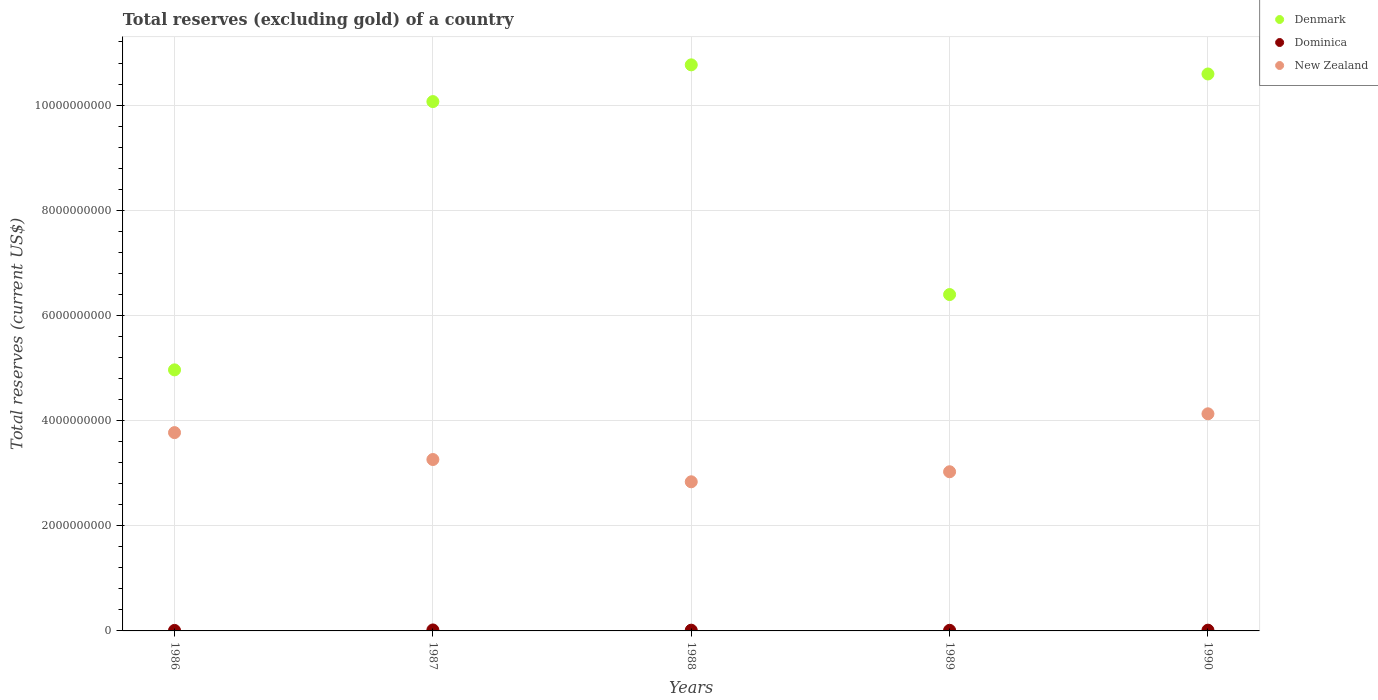What is the total reserves (excluding gold) in Denmark in 1987?
Your answer should be very brief. 1.01e+1. Across all years, what is the maximum total reserves (excluding gold) in New Zealand?
Your response must be concise. 4.13e+09. Across all years, what is the minimum total reserves (excluding gold) in New Zealand?
Keep it short and to the point. 2.84e+09. In which year was the total reserves (excluding gold) in New Zealand maximum?
Provide a succinct answer. 1990. In which year was the total reserves (excluding gold) in Denmark minimum?
Your response must be concise. 1986. What is the total total reserves (excluding gold) in Dominica in the graph?
Keep it short and to the point. 6.82e+07. What is the difference between the total reserves (excluding gold) in Dominica in 1988 and that in 1990?
Provide a succinct answer. -3.99e+05. What is the difference between the total reserves (excluding gold) in Dominica in 1989 and the total reserves (excluding gold) in Denmark in 1987?
Offer a terse response. -1.01e+1. What is the average total reserves (excluding gold) in Denmark per year?
Provide a short and direct response. 8.56e+09. In the year 1990, what is the difference between the total reserves (excluding gold) in Dominica and total reserves (excluding gold) in Denmark?
Offer a terse response. -1.06e+1. In how many years, is the total reserves (excluding gold) in Dominica greater than 4800000000 US$?
Provide a short and direct response. 0. What is the ratio of the total reserves (excluding gold) in New Zealand in 1986 to that in 1987?
Your answer should be very brief. 1.16. What is the difference between the highest and the second highest total reserves (excluding gold) in Dominica?
Give a very brief answer. 3.96e+06. What is the difference between the highest and the lowest total reserves (excluding gold) in New Zealand?
Offer a very short reply. 1.29e+09. Is the sum of the total reserves (excluding gold) in New Zealand in 1987 and 1988 greater than the maximum total reserves (excluding gold) in Denmark across all years?
Keep it short and to the point. No. Is it the case that in every year, the sum of the total reserves (excluding gold) in Dominica and total reserves (excluding gold) in Denmark  is greater than the total reserves (excluding gold) in New Zealand?
Your response must be concise. Yes. Is the total reserves (excluding gold) in New Zealand strictly less than the total reserves (excluding gold) in Denmark over the years?
Keep it short and to the point. Yes. How many dotlines are there?
Provide a succinct answer. 3. How many years are there in the graph?
Provide a succinct answer. 5. What is the difference between two consecutive major ticks on the Y-axis?
Provide a short and direct response. 2.00e+09. Does the graph contain grids?
Your response must be concise. Yes. Where does the legend appear in the graph?
Your response must be concise. Top right. How many legend labels are there?
Keep it short and to the point. 3. What is the title of the graph?
Your response must be concise. Total reserves (excluding gold) of a country. What is the label or title of the Y-axis?
Make the answer very short. Total reserves (current US$). What is the Total reserves (current US$) in Denmark in 1986?
Provide a short and direct response. 4.96e+09. What is the Total reserves (current US$) in Dominica in 1986?
Provide a short and direct response. 9.59e+06. What is the Total reserves (current US$) in New Zealand in 1986?
Provide a succinct answer. 3.77e+09. What is the Total reserves (current US$) of Denmark in 1987?
Ensure brevity in your answer.  1.01e+1. What is the Total reserves (current US$) of Dominica in 1987?
Keep it short and to the point. 1.84e+07. What is the Total reserves (current US$) of New Zealand in 1987?
Make the answer very short. 3.26e+09. What is the Total reserves (current US$) of Denmark in 1988?
Your answer should be very brief. 1.08e+1. What is the Total reserves (current US$) of Dominica in 1988?
Offer a terse response. 1.41e+07. What is the Total reserves (current US$) in New Zealand in 1988?
Your answer should be compact. 2.84e+09. What is the Total reserves (current US$) of Denmark in 1989?
Offer a terse response. 6.40e+09. What is the Total reserves (current US$) of Dominica in 1989?
Provide a succinct answer. 1.17e+07. What is the Total reserves (current US$) in New Zealand in 1989?
Your response must be concise. 3.03e+09. What is the Total reserves (current US$) of Denmark in 1990?
Make the answer very short. 1.06e+1. What is the Total reserves (current US$) of Dominica in 1990?
Provide a short and direct response. 1.45e+07. What is the Total reserves (current US$) of New Zealand in 1990?
Offer a terse response. 4.13e+09. Across all years, what is the maximum Total reserves (current US$) in Denmark?
Offer a very short reply. 1.08e+1. Across all years, what is the maximum Total reserves (current US$) of Dominica?
Ensure brevity in your answer.  1.84e+07. Across all years, what is the maximum Total reserves (current US$) of New Zealand?
Give a very brief answer. 4.13e+09. Across all years, what is the minimum Total reserves (current US$) in Denmark?
Your answer should be very brief. 4.96e+09. Across all years, what is the minimum Total reserves (current US$) of Dominica?
Provide a short and direct response. 9.59e+06. Across all years, what is the minimum Total reserves (current US$) of New Zealand?
Make the answer very short. 2.84e+09. What is the total Total reserves (current US$) in Denmark in the graph?
Provide a short and direct response. 4.28e+1. What is the total Total reserves (current US$) in Dominica in the graph?
Make the answer very short. 6.82e+07. What is the total Total reserves (current US$) in New Zealand in the graph?
Provide a succinct answer. 1.70e+1. What is the difference between the Total reserves (current US$) in Denmark in 1986 and that in 1987?
Provide a succinct answer. -5.10e+09. What is the difference between the Total reserves (current US$) in Dominica in 1986 and that in 1987?
Give a very brief answer. -8.83e+06. What is the difference between the Total reserves (current US$) in New Zealand in 1986 and that in 1987?
Offer a very short reply. 5.12e+08. What is the difference between the Total reserves (current US$) of Denmark in 1986 and that in 1988?
Provide a succinct answer. -5.80e+09. What is the difference between the Total reserves (current US$) of Dominica in 1986 and that in 1988?
Your answer should be very brief. -4.47e+06. What is the difference between the Total reserves (current US$) of New Zealand in 1986 and that in 1988?
Ensure brevity in your answer.  9.35e+08. What is the difference between the Total reserves (current US$) of Denmark in 1986 and that in 1989?
Ensure brevity in your answer.  -1.43e+09. What is the difference between the Total reserves (current US$) of Dominica in 1986 and that in 1989?
Your response must be concise. -2.09e+06. What is the difference between the Total reserves (current US$) in New Zealand in 1986 and that in 1989?
Keep it short and to the point. 7.44e+08. What is the difference between the Total reserves (current US$) of Denmark in 1986 and that in 1990?
Your response must be concise. -5.63e+09. What is the difference between the Total reserves (current US$) in Dominica in 1986 and that in 1990?
Provide a succinct answer. -4.87e+06. What is the difference between the Total reserves (current US$) in New Zealand in 1986 and that in 1990?
Make the answer very short. -3.58e+08. What is the difference between the Total reserves (current US$) in Denmark in 1987 and that in 1988?
Offer a very short reply. -6.99e+08. What is the difference between the Total reserves (current US$) of Dominica in 1987 and that in 1988?
Make the answer very short. 4.36e+06. What is the difference between the Total reserves (current US$) in New Zealand in 1987 and that in 1988?
Your response must be concise. 4.24e+08. What is the difference between the Total reserves (current US$) in Denmark in 1987 and that in 1989?
Provide a succinct answer. 3.67e+09. What is the difference between the Total reserves (current US$) of Dominica in 1987 and that in 1989?
Keep it short and to the point. 6.74e+06. What is the difference between the Total reserves (current US$) in New Zealand in 1987 and that in 1989?
Offer a very short reply. 2.33e+08. What is the difference between the Total reserves (current US$) in Denmark in 1987 and that in 1990?
Keep it short and to the point. -5.25e+08. What is the difference between the Total reserves (current US$) of Dominica in 1987 and that in 1990?
Provide a short and direct response. 3.96e+06. What is the difference between the Total reserves (current US$) in New Zealand in 1987 and that in 1990?
Your answer should be compact. -8.69e+08. What is the difference between the Total reserves (current US$) of Denmark in 1988 and that in 1989?
Offer a terse response. 4.37e+09. What is the difference between the Total reserves (current US$) of Dominica in 1988 and that in 1989?
Keep it short and to the point. 2.38e+06. What is the difference between the Total reserves (current US$) in New Zealand in 1988 and that in 1989?
Offer a terse response. -1.91e+08. What is the difference between the Total reserves (current US$) in Denmark in 1988 and that in 1990?
Give a very brief answer. 1.74e+08. What is the difference between the Total reserves (current US$) of Dominica in 1988 and that in 1990?
Your response must be concise. -3.99e+05. What is the difference between the Total reserves (current US$) in New Zealand in 1988 and that in 1990?
Provide a succinct answer. -1.29e+09. What is the difference between the Total reserves (current US$) in Denmark in 1989 and that in 1990?
Keep it short and to the point. -4.19e+09. What is the difference between the Total reserves (current US$) in Dominica in 1989 and that in 1990?
Ensure brevity in your answer.  -2.78e+06. What is the difference between the Total reserves (current US$) in New Zealand in 1989 and that in 1990?
Provide a short and direct response. -1.10e+09. What is the difference between the Total reserves (current US$) of Denmark in 1986 and the Total reserves (current US$) of Dominica in 1987?
Your response must be concise. 4.95e+09. What is the difference between the Total reserves (current US$) of Denmark in 1986 and the Total reserves (current US$) of New Zealand in 1987?
Make the answer very short. 1.70e+09. What is the difference between the Total reserves (current US$) in Dominica in 1986 and the Total reserves (current US$) in New Zealand in 1987?
Offer a terse response. -3.25e+09. What is the difference between the Total reserves (current US$) of Denmark in 1986 and the Total reserves (current US$) of Dominica in 1988?
Provide a short and direct response. 4.95e+09. What is the difference between the Total reserves (current US$) in Denmark in 1986 and the Total reserves (current US$) in New Zealand in 1988?
Your answer should be very brief. 2.13e+09. What is the difference between the Total reserves (current US$) of Dominica in 1986 and the Total reserves (current US$) of New Zealand in 1988?
Ensure brevity in your answer.  -2.83e+09. What is the difference between the Total reserves (current US$) of Denmark in 1986 and the Total reserves (current US$) of Dominica in 1989?
Offer a terse response. 4.95e+09. What is the difference between the Total reserves (current US$) of Denmark in 1986 and the Total reserves (current US$) of New Zealand in 1989?
Ensure brevity in your answer.  1.94e+09. What is the difference between the Total reserves (current US$) in Dominica in 1986 and the Total reserves (current US$) in New Zealand in 1989?
Give a very brief answer. -3.02e+09. What is the difference between the Total reserves (current US$) of Denmark in 1986 and the Total reserves (current US$) of Dominica in 1990?
Provide a succinct answer. 4.95e+09. What is the difference between the Total reserves (current US$) of Denmark in 1986 and the Total reserves (current US$) of New Zealand in 1990?
Keep it short and to the point. 8.36e+08. What is the difference between the Total reserves (current US$) in Dominica in 1986 and the Total reserves (current US$) in New Zealand in 1990?
Provide a succinct answer. -4.12e+09. What is the difference between the Total reserves (current US$) in Denmark in 1987 and the Total reserves (current US$) in Dominica in 1988?
Provide a succinct answer. 1.01e+1. What is the difference between the Total reserves (current US$) in Denmark in 1987 and the Total reserves (current US$) in New Zealand in 1988?
Your answer should be very brief. 7.23e+09. What is the difference between the Total reserves (current US$) in Dominica in 1987 and the Total reserves (current US$) in New Zealand in 1988?
Provide a succinct answer. -2.82e+09. What is the difference between the Total reserves (current US$) of Denmark in 1987 and the Total reserves (current US$) of Dominica in 1989?
Keep it short and to the point. 1.01e+1. What is the difference between the Total reserves (current US$) of Denmark in 1987 and the Total reserves (current US$) of New Zealand in 1989?
Make the answer very short. 7.04e+09. What is the difference between the Total reserves (current US$) of Dominica in 1987 and the Total reserves (current US$) of New Zealand in 1989?
Provide a short and direct response. -3.01e+09. What is the difference between the Total reserves (current US$) of Denmark in 1987 and the Total reserves (current US$) of Dominica in 1990?
Keep it short and to the point. 1.01e+1. What is the difference between the Total reserves (current US$) in Denmark in 1987 and the Total reserves (current US$) in New Zealand in 1990?
Your answer should be very brief. 5.94e+09. What is the difference between the Total reserves (current US$) in Dominica in 1987 and the Total reserves (current US$) in New Zealand in 1990?
Keep it short and to the point. -4.11e+09. What is the difference between the Total reserves (current US$) of Denmark in 1988 and the Total reserves (current US$) of Dominica in 1989?
Offer a terse response. 1.08e+1. What is the difference between the Total reserves (current US$) in Denmark in 1988 and the Total reserves (current US$) in New Zealand in 1989?
Ensure brevity in your answer.  7.74e+09. What is the difference between the Total reserves (current US$) in Dominica in 1988 and the Total reserves (current US$) in New Zealand in 1989?
Ensure brevity in your answer.  -3.01e+09. What is the difference between the Total reserves (current US$) of Denmark in 1988 and the Total reserves (current US$) of Dominica in 1990?
Your response must be concise. 1.08e+1. What is the difference between the Total reserves (current US$) in Denmark in 1988 and the Total reserves (current US$) in New Zealand in 1990?
Ensure brevity in your answer.  6.64e+09. What is the difference between the Total reserves (current US$) in Dominica in 1988 and the Total reserves (current US$) in New Zealand in 1990?
Make the answer very short. -4.11e+09. What is the difference between the Total reserves (current US$) of Denmark in 1989 and the Total reserves (current US$) of Dominica in 1990?
Offer a terse response. 6.38e+09. What is the difference between the Total reserves (current US$) of Denmark in 1989 and the Total reserves (current US$) of New Zealand in 1990?
Make the answer very short. 2.27e+09. What is the difference between the Total reserves (current US$) in Dominica in 1989 and the Total reserves (current US$) in New Zealand in 1990?
Your response must be concise. -4.12e+09. What is the average Total reserves (current US$) in Denmark per year?
Keep it short and to the point. 8.56e+09. What is the average Total reserves (current US$) in Dominica per year?
Make the answer very short. 1.36e+07. What is the average Total reserves (current US$) in New Zealand per year?
Your response must be concise. 3.40e+09. In the year 1986, what is the difference between the Total reserves (current US$) of Denmark and Total reserves (current US$) of Dominica?
Offer a terse response. 4.95e+09. In the year 1986, what is the difference between the Total reserves (current US$) of Denmark and Total reserves (current US$) of New Zealand?
Ensure brevity in your answer.  1.19e+09. In the year 1986, what is the difference between the Total reserves (current US$) of Dominica and Total reserves (current US$) of New Zealand?
Your response must be concise. -3.76e+09. In the year 1987, what is the difference between the Total reserves (current US$) in Denmark and Total reserves (current US$) in Dominica?
Ensure brevity in your answer.  1.00e+1. In the year 1987, what is the difference between the Total reserves (current US$) of Denmark and Total reserves (current US$) of New Zealand?
Keep it short and to the point. 6.81e+09. In the year 1987, what is the difference between the Total reserves (current US$) in Dominica and Total reserves (current US$) in New Zealand?
Keep it short and to the point. -3.24e+09. In the year 1988, what is the difference between the Total reserves (current US$) in Denmark and Total reserves (current US$) in Dominica?
Offer a terse response. 1.08e+1. In the year 1988, what is the difference between the Total reserves (current US$) in Denmark and Total reserves (current US$) in New Zealand?
Offer a terse response. 7.93e+09. In the year 1988, what is the difference between the Total reserves (current US$) in Dominica and Total reserves (current US$) in New Zealand?
Make the answer very short. -2.82e+09. In the year 1989, what is the difference between the Total reserves (current US$) in Denmark and Total reserves (current US$) in Dominica?
Offer a very short reply. 6.39e+09. In the year 1989, what is the difference between the Total reserves (current US$) in Denmark and Total reserves (current US$) in New Zealand?
Provide a succinct answer. 3.37e+09. In the year 1989, what is the difference between the Total reserves (current US$) of Dominica and Total reserves (current US$) of New Zealand?
Offer a very short reply. -3.02e+09. In the year 1990, what is the difference between the Total reserves (current US$) in Denmark and Total reserves (current US$) in Dominica?
Offer a terse response. 1.06e+1. In the year 1990, what is the difference between the Total reserves (current US$) of Denmark and Total reserves (current US$) of New Zealand?
Ensure brevity in your answer.  6.46e+09. In the year 1990, what is the difference between the Total reserves (current US$) of Dominica and Total reserves (current US$) of New Zealand?
Your answer should be compact. -4.11e+09. What is the ratio of the Total reserves (current US$) of Denmark in 1986 to that in 1987?
Ensure brevity in your answer.  0.49. What is the ratio of the Total reserves (current US$) of Dominica in 1986 to that in 1987?
Offer a very short reply. 0.52. What is the ratio of the Total reserves (current US$) in New Zealand in 1986 to that in 1987?
Offer a very short reply. 1.16. What is the ratio of the Total reserves (current US$) in Denmark in 1986 to that in 1988?
Your response must be concise. 0.46. What is the ratio of the Total reserves (current US$) in Dominica in 1986 to that in 1988?
Offer a very short reply. 0.68. What is the ratio of the Total reserves (current US$) in New Zealand in 1986 to that in 1988?
Your answer should be very brief. 1.33. What is the ratio of the Total reserves (current US$) of Denmark in 1986 to that in 1989?
Provide a succinct answer. 0.78. What is the ratio of the Total reserves (current US$) of Dominica in 1986 to that in 1989?
Keep it short and to the point. 0.82. What is the ratio of the Total reserves (current US$) in New Zealand in 1986 to that in 1989?
Provide a short and direct response. 1.25. What is the ratio of the Total reserves (current US$) of Denmark in 1986 to that in 1990?
Offer a very short reply. 0.47. What is the ratio of the Total reserves (current US$) of Dominica in 1986 to that in 1990?
Make the answer very short. 0.66. What is the ratio of the Total reserves (current US$) in New Zealand in 1986 to that in 1990?
Give a very brief answer. 0.91. What is the ratio of the Total reserves (current US$) in Denmark in 1987 to that in 1988?
Your answer should be very brief. 0.94. What is the ratio of the Total reserves (current US$) in Dominica in 1987 to that in 1988?
Make the answer very short. 1.31. What is the ratio of the Total reserves (current US$) of New Zealand in 1987 to that in 1988?
Provide a succinct answer. 1.15. What is the ratio of the Total reserves (current US$) of Denmark in 1987 to that in 1989?
Keep it short and to the point. 1.57. What is the ratio of the Total reserves (current US$) of Dominica in 1987 to that in 1989?
Your answer should be very brief. 1.58. What is the ratio of the Total reserves (current US$) of Denmark in 1987 to that in 1990?
Make the answer very short. 0.95. What is the ratio of the Total reserves (current US$) of Dominica in 1987 to that in 1990?
Make the answer very short. 1.27. What is the ratio of the Total reserves (current US$) of New Zealand in 1987 to that in 1990?
Offer a very short reply. 0.79. What is the ratio of the Total reserves (current US$) of Denmark in 1988 to that in 1989?
Keep it short and to the point. 1.68. What is the ratio of the Total reserves (current US$) of Dominica in 1988 to that in 1989?
Your answer should be compact. 1.2. What is the ratio of the Total reserves (current US$) in New Zealand in 1988 to that in 1989?
Your answer should be compact. 0.94. What is the ratio of the Total reserves (current US$) of Denmark in 1988 to that in 1990?
Keep it short and to the point. 1.02. What is the ratio of the Total reserves (current US$) in Dominica in 1988 to that in 1990?
Offer a very short reply. 0.97. What is the ratio of the Total reserves (current US$) of New Zealand in 1988 to that in 1990?
Make the answer very short. 0.69. What is the ratio of the Total reserves (current US$) in Denmark in 1989 to that in 1990?
Your answer should be compact. 0.6. What is the ratio of the Total reserves (current US$) in Dominica in 1989 to that in 1990?
Keep it short and to the point. 0.81. What is the ratio of the Total reserves (current US$) of New Zealand in 1989 to that in 1990?
Ensure brevity in your answer.  0.73. What is the difference between the highest and the second highest Total reserves (current US$) in Denmark?
Your answer should be very brief. 1.74e+08. What is the difference between the highest and the second highest Total reserves (current US$) of Dominica?
Provide a short and direct response. 3.96e+06. What is the difference between the highest and the second highest Total reserves (current US$) in New Zealand?
Make the answer very short. 3.58e+08. What is the difference between the highest and the lowest Total reserves (current US$) in Denmark?
Give a very brief answer. 5.80e+09. What is the difference between the highest and the lowest Total reserves (current US$) in Dominica?
Your response must be concise. 8.83e+06. What is the difference between the highest and the lowest Total reserves (current US$) in New Zealand?
Provide a succinct answer. 1.29e+09. 